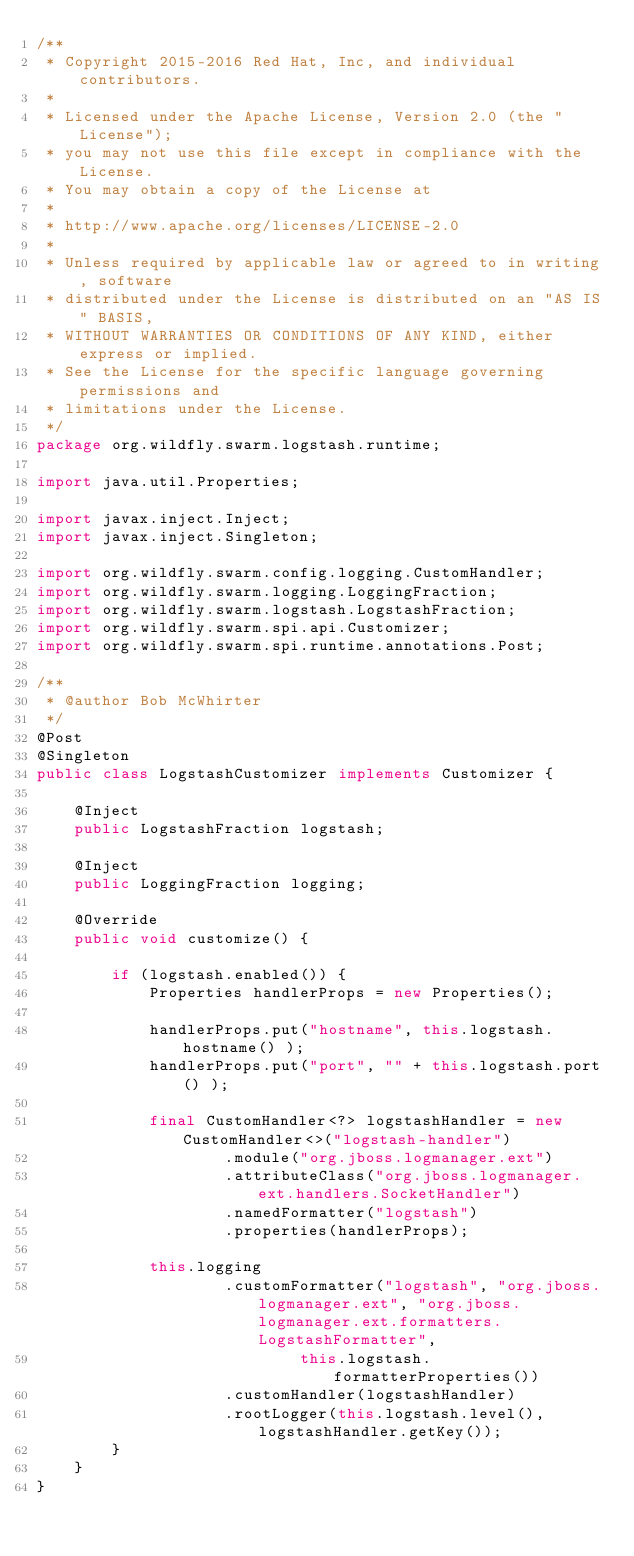Convert code to text. <code><loc_0><loc_0><loc_500><loc_500><_Java_>/**
 * Copyright 2015-2016 Red Hat, Inc, and individual contributors.
 *
 * Licensed under the Apache License, Version 2.0 (the "License");
 * you may not use this file except in compliance with the License.
 * You may obtain a copy of the License at
 *
 * http://www.apache.org/licenses/LICENSE-2.0
 *
 * Unless required by applicable law or agreed to in writing, software
 * distributed under the License is distributed on an "AS IS" BASIS,
 * WITHOUT WARRANTIES OR CONDITIONS OF ANY KIND, either express or implied.
 * See the License for the specific language governing permissions and
 * limitations under the License.
 */
package org.wildfly.swarm.logstash.runtime;

import java.util.Properties;

import javax.inject.Inject;
import javax.inject.Singleton;

import org.wildfly.swarm.config.logging.CustomHandler;
import org.wildfly.swarm.logging.LoggingFraction;
import org.wildfly.swarm.logstash.LogstashFraction;
import org.wildfly.swarm.spi.api.Customizer;
import org.wildfly.swarm.spi.runtime.annotations.Post;

/**
 * @author Bob McWhirter
 */
@Post
@Singleton
public class LogstashCustomizer implements Customizer {

    @Inject
    public LogstashFraction logstash;

    @Inject
    public LoggingFraction logging;

    @Override
    public void customize() {

        if (logstash.enabled()) {
            Properties handlerProps = new Properties();

            handlerProps.put("hostname", this.logstash.hostname() );
            handlerProps.put("port", "" + this.logstash.port() );

            final CustomHandler<?> logstashHandler = new CustomHandler<>("logstash-handler")
                    .module("org.jboss.logmanager.ext")
                    .attributeClass("org.jboss.logmanager.ext.handlers.SocketHandler")
                    .namedFormatter("logstash")
                    .properties(handlerProps);

            this.logging
                    .customFormatter("logstash", "org.jboss.logmanager.ext", "org.jboss.logmanager.ext.formatters.LogstashFormatter",
                            this.logstash.formatterProperties())
                    .customHandler(logstashHandler)
                    .rootLogger(this.logstash.level(), logstashHandler.getKey());
        }
    }
}
</code> 